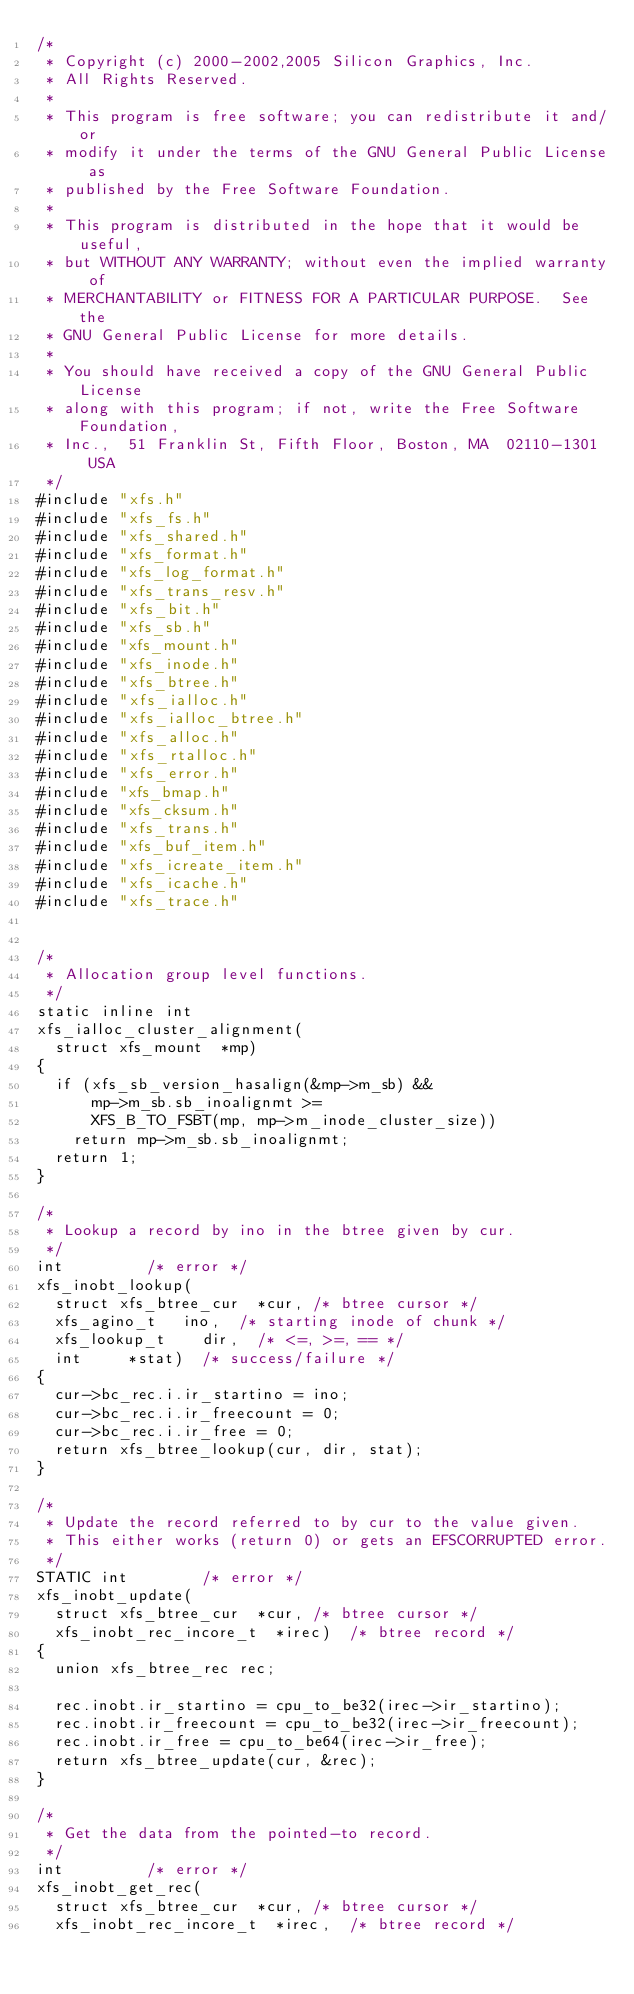Convert code to text. <code><loc_0><loc_0><loc_500><loc_500><_C_>/*
 * Copyright (c) 2000-2002,2005 Silicon Graphics, Inc.
 * All Rights Reserved.
 *
 * This program is free software; you can redistribute it and/or
 * modify it under the terms of the GNU General Public License as
 * published by the Free Software Foundation.
 *
 * This program is distributed in the hope that it would be useful,
 * but WITHOUT ANY WARRANTY; without even the implied warranty of
 * MERCHANTABILITY or FITNESS FOR A PARTICULAR PURPOSE.  See the
 * GNU General Public License for more details.
 *
 * You should have received a copy of the GNU General Public License
 * along with this program; if not, write the Free Software Foundation,
 * Inc.,  51 Franklin St, Fifth Floor, Boston, MA  02110-1301  USA
 */
#include "xfs.h"
#include "xfs_fs.h"
#include "xfs_shared.h"
#include "xfs_format.h"
#include "xfs_log_format.h"
#include "xfs_trans_resv.h"
#include "xfs_bit.h"
#include "xfs_sb.h"
#include "xfs_mount.h"
#include "xfs_inode.h"
#include "xfs_btree.h"
#include "xfs_ialloc.h"
#include "xfs_ialloc_btree.h"
#include "xfs_alloc.h"
#include "xfs_rtalloc.h"
#include "xfs_error.h"
#include "xfs_bmap.h"
#include "xfs_cksum.h"
#include "xfs_trans.h"
#include "xfs_buf_item.h"
#include "xfs_icreate_item.h"
#include "xfs_icache.h"
#include "xfs_trace.h"


/*
 * Allocation group level functions.
 */
static inline int
xfs_ialloc_cluster_alignment(
	struct xfs_mount	*mp)
{
	if (xfs_sb_version_hasalign(&mp->m_sb) &&
	    mp->m_sb.sb_inoalignmt >=
			XFS_B_TO_FSBT(mp, mp->m_inode_cluster_size))
		return mp->m_sb.sb_inoalignmt;
	return 1;
}

/*
 * Lookup a record by ino in the btree given by cur.
 */
int					/* error */
xfs_inobt_lookup(
	struct xfs_btree_cur	*cur,	/* btree cursor */
	xfs_agino_t		ino,	/* starting inode of chunk */
	xfs_lookup_t		dir,	/* <=, >=, == */
	int			*stat)	/* success/failure */
{
	cur->bc_rec.i.ir_startino = ino;
	cur->bc_rec.i.ir_freecount = 0;
	cur->bc_rec.i.ir_free = 0;
	return xfs_btree_lookup(cur, dir, stat);
}

/*
 * Update the record referred to by cur to the value given.
 * This either works (return 0) or gets an EFSCORRUPTED error.
 */
STATIC int				/* error */
xfs_inobt_update(
	struct xfs_btree_cur	*cur,	/* btree cursor */
	xfs_inobt_rec_incore_t	*irec)	/* btree record */
{
	union xfs_btree_rec	rec;

	rec.inobt.ir_startino = cpu_to_be32(irec->ir_startino);
	rec.inobt.ir_freecount = cpu_to_be32(irec->ir_freecount);
	rec.inobt.ir_free = cpu_to_be64(irec->ir_free);
	return xfs_btree_update(cur, &rec);
}

/*
 * Get the data from the pointed-to record.
 */
int					/* error */
xfs_inobt_get_rec(
	struct xfs_btree_cur	*cur,	/* btree cursor */
	xfs_inobt_rec_incore_t	*irec,	/* btree record */</code> 